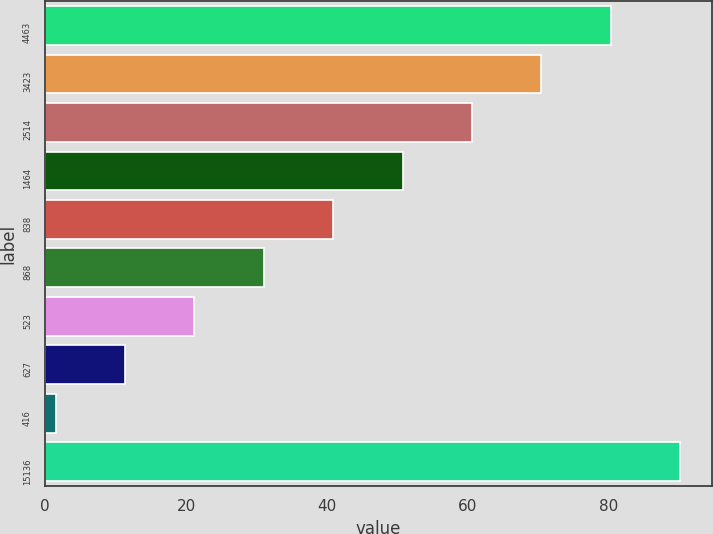<chart> <loc_0><loc_0><loc_500><loc_500><bar_chart><fcel>4463<fcel>3423<fcel>2514<fcel>1464<fcel>838<fcel>868<fcel>523<fcel>627<fcel>416<fcel>15136<nl><fcel>80.3<fcel>70.45<fcel>60.6<fcel>50.75<fcel>40.9<fcel>31.05<fcel>21.2<fcel>11.35<fcel>1.5<fcel>90.15<nl></chart> 